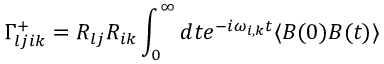<formula> <loc_0><loc_0><loc_500><loc_500>\Gamma _ { l j i k } ^ { + } = R _ { l j } R _ { i k } \int _ { 0 } ^ { \infty } d t e ^ { - i \omega _ { i , k } t } \langle B ( 0 ) B ( t ) \rangle</formula> 